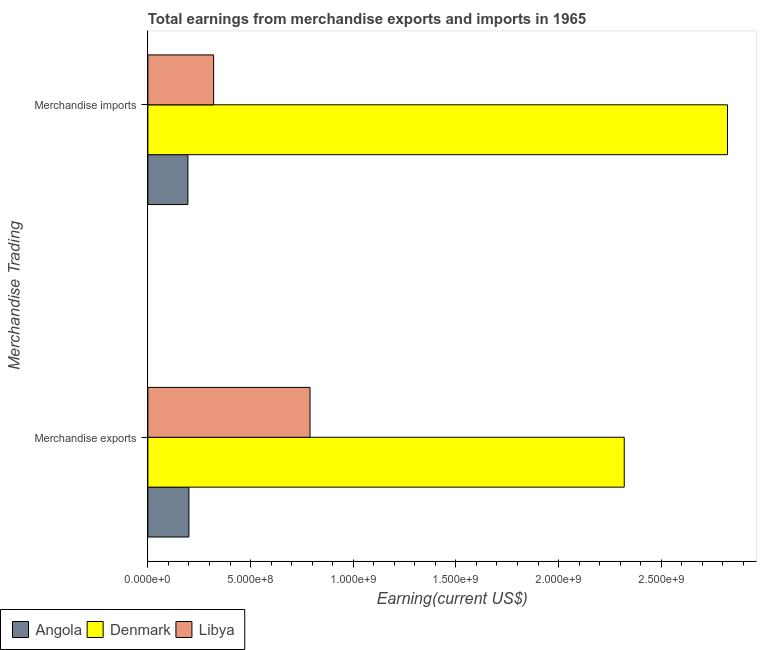How many different coloured bars are there?
Offer a very short reply. 3. Are the number of bars per tick equal to the number of legend labels?
Offer a very short reply. Yes. Are the number of bars on each tick of the Y-axis equal?
Provide a short and direct response. Yes. How many bars are there on the 2nd tick from the top?
Give a very brief answer. 3. How many bars are there on the 1st tick from the bottom?
Give a very brief answer. 3. What is the label of the 2nd group of bars from the top?
Offer a terse response. Merchandise exports. What is the earnings from merchandise exports in Angola?
Keep it short and to the point. 2.00e+08. Across all countries, what is the maximum earnings from merchandise exports?
Offer a terse response. 2.32e+09. Across all countries, what is the minimum earnings from merchandise imports?
Offer a terse response. 1.95e+08. In which country was the earnings from merchandise imports minimum?
Provide a short and direct response. Angola. What is the total earnings from merchandise exports in the graph?
Give a very brief answer. 3.31e+09. What is the difference between the earnings from merchandise exports in Denmark and that in Libya?
Your answer should be very brief. 1.53e+09. What is the difference between the earnings from merchandise imports in Angola and the earnings from merchandise exports in Denmark?
Keep it short and to the point. -2.12e+09. What is the average earnings from merchandise exports per country?
Keep it short and to the point. 1.10e+09. What is the difference between the earnings from merchandise exports and earnings from merchandise imports in Denmark?
Your answer should be compact. -5.03e+08. What is the ratio of the earnings from merchandise exports in Libya to that in Angola?
Give a very brief answer. 3.95. In how many countries, is the earnings from merchandise exports greater than the average earnings from merchandise exports taken over all countries?
Keep it short and to the point. 1. What does the 2nd bar from the top in Merchandise exports represents?
Offer a terse response. Denmark. What does the 3rd bar from the bottom in Merchandise imports represents?
Ensure brevity in your answer.  Libya. How many countries are there in the graph?
Provide a succinct answer. 3. What is the difference between two consecutive major ticks on the X-axis?
Make the answer very short. 5.00e+08. How many legend labels are there?
Offer a terse response. 3. How are the legend labels stacked?
Make the answer very short. Horizontal. What is the title of the graph?
Make the answer very short. Total earnings from merchandise exports and imports in 1965. What is the label or title of the X-axis?
Your response must be concise. Earning(current US$). What is the label or title of the Y-axis?
Make the answer very short. Merchandise Trading. What is the Earning(current US$) in Angola in Merchandise exports?
Your answer should be very brief. 2.00e+08. What is the Earning(current US$) in Denmark in Merchandise exports?
Your answer should be compact. 2.32e+09. What is the Earning(current US$) in Libya in Merchandise exports?
Your response must be concise. 7.90e+08. What is the Earning(current US$) of Angola in Merchandise imports?
Keep it short and to the point. 1.95e+08. What is the Earning(current US$) in Denmark in Merchandise imports?
Your answer should be very brief. 2.82e+09. What is the Earning(current US$) in Libya in Merchandise imports?
Ensure brevity in your answer.  3.20e+08. Across all Merchandise Trading, what is the maximum Earning(current US$) in Angola?
Ensure brevity in your answer.  2.00e+08. Across all Merchandise Trading, what is the maximum Earning(current US$) of Denmark?
Offer a very short reply. 2.82e+09. Across all Merchandise Trading, what is the maximum Earning(current US$) in Libya?
Provide a succinct answer. 7.90e+08. Across all Merchandise Trading, what is the minimum Earning(current US$) of Angola?
Make the answer very short. 1.95e+08. Across all Merchandise Trading, what is the minimum Earning(current US$) in Denmark?
Your answer should be compact. 2.32e+09. Across all Merchandise Trading, what is the minimum Earning(current US$) of Libya?
Offer a terse response. 3.20e+08. What is the total Earning(current US$) in Angola in the graph?
Your answer should be very brief. 3.95e+08. What is the total Earning(current US$) of Denmark in the graph?
Keep it short and to the point. 5.14e+09. What is the total Earning(current US$) in Libya in the graph?
Make the answer very short. 1.11e+09. What is the difference between the Earning(current US$) of Angola in Merchandise exports and that in Merchandise imports?
Offer a terse response. 5.00e+06. What is the difference between the Earning(current US$) of Denmark in Merchandise exports and that in Merchandise imports?
Offer a terse response. -5.03e+08. What is the difference between the Earning(current US$) in Libya in Merchandise exports and that in Merchandise imports?
Your response must be concise. 4.69e+08. What is the difference between the Earning(current US$) in Angola in Merchandise exports and the Earning(current US$) in Denmark in Merchandise imports?
Offer a terse response. -2.62e+09. What is the difference between the Earning(current US$) of Angola in Merchandise exports and the Earning(current US$) of Libya in Merchandise imports?
Your response must be concise. -1.20e+08. What is the difference between the Earning(current US$) in Denmark in Merchandise exports and the Earning(current US$) in Libya in Merchandise imports?
Keep it short and to the point. 2.00e+09. What is the average Earning(current US$) of Angola per Merchandise Trading?
Your response must be concise. 1.98e+08. What is the average Earning(current US$) of Denmark per Merchandise Trading?
Offer a terse response. 2.57e+09. What is the average Earning(current US$) of Libya per Merchandise Trading?
Offer a terse response. 5.55e+08. What is the difference between the Earning(current US$) in Angola and Earning(current US$) in Denmark in Merchandise exports?
Make the answer very short. -2.12e+09. What is the difference between the Earning(current US$) in Angola and Earning(current US$) in Libya in Merchandise exports?
Offer a terse response. -5.90e+08. What is the difference between the Earning(current US$) of Denmark and Earning(current US$) of Libya in Merchandise exports?
Provide a short and direct response. 1.53e+09. What is the difference between the Earning(current US$) in Angola and Earning(current US$) in Denmark in Merchandise imports?
Keep it short and to the point. -2.63e+09. What is the difference between the Earning(current US$) in Angola and Earning(current US$) in Libya in Merchandise imports?
Keep it short and to the point. -1.25e+08. What is the difference between the Earning(current US$) in Denmark and Earning(current US$) in Libya in Merchandise imports?
Give a very brief answer. 2.50e+09. What is the ratio of the Earning(current US$) of Angola in Merchandise exports to that in Merchandise imports?
Give a very brief answer. 1.03. What is the ratio of the Earning(current US$) of Denmark in Merchandise exports to that in Merchandise imports?
Ensure brevity in your answer.  0.82. What is the ratio of the Earning(current US$) in Libya in Merchandise exports to that in Merchandise imports?
Give a very brief answer. 2.46. What is the difference between the highest and the second highest Earning(current US$) of Angola?
Offer a very short reply. 5.00e+06. What is the difference between the highest and the second highest Earning(current US$) of Denmark?
Make the answer very short. 5.03e+08. What is the difference between the highest and the second highest Earning(current US$) in Libya?
Provide a short and direct response. 4.69e+08. What is the difference between the highest and the lowest Earning(current US$) of Angola?
Give a very brief answer. 5.00e+06. What is the difference between the highest and the lowest Earning(current US$) in Denmark?
Offer a very short reply. 5.03e+08. What is the difference between the highest and the lowest Earning(current US$) in Libya?
Make the answer very short. 4.69e+08. 